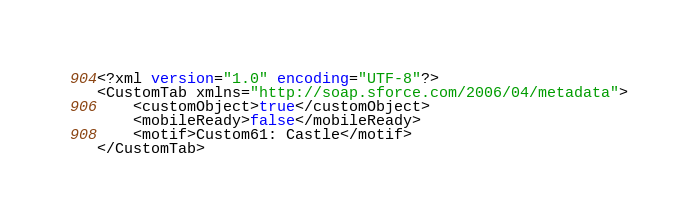Convert code to text. <code><loc_0><loc_0><loc_500><loc_500><_SQL_><?xml version="1.0" encoding="UTF-8"?>
<CustomTab xmlns="http://soap.sforce.com/2006/04/metadata">
    <customObject>true</customObject>
    <mobileReady>false</mobileReady>
    <motif>Custom61: Castle</motif>
</CustomTab>
</code> 